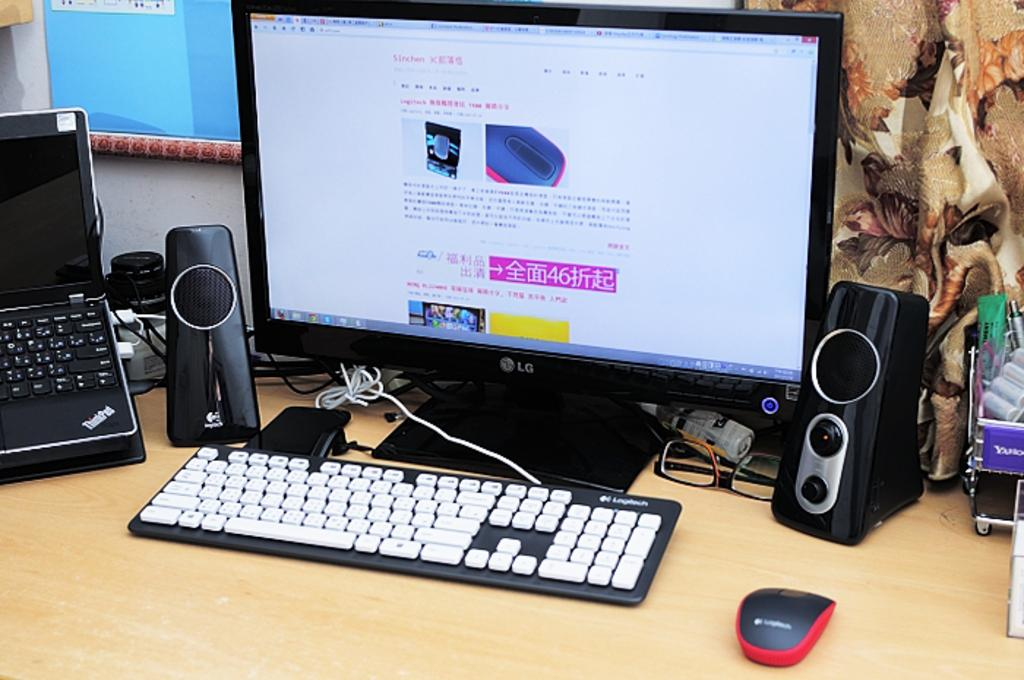What type of electronic device is visible in the image? There is a monitor in the image. What is used for input with the monitor? There is a keyboard in the image. What is used for audio output in the image? There are speakers in the image. What is used for controlling the cursor on the monitor? There is a mouse in the image. What are the small dots visible on the monitor? There are specs in the image. What type of portable computer is present in the image? There is a laptop in the image. What other objects can be seen on the table in the image? There are other objects on the table in the image. What can be seen hanging on the wall in the background of the image? There are objects hanging on the wall in the background of the image. How many alarms are present in the image? There are no alarms visible in the image. What type of seafood is present in the image? There is no seafood present in the image. 